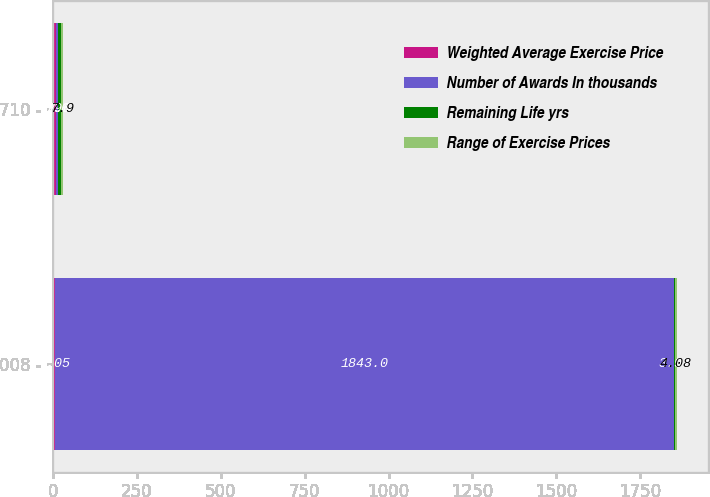Convert chart. <chart><loc_0><loc_0><loc_500><loc_500><stacked_bar_chart><ecel><fcel>008 -<fcel>710 -<nl><fcel>Weighted Average Exercise Price<fcel>7.05<fcel>7.93<nl><fcel>Number of Awards In thousands<fcel>1843<fcel>7.6<nl><fcel>Remaining Life yrs<fcel>3.97<fcel>7.6<nl><fcel>Range of Exercise Prices<fcel>4.08<fcel>7.9<nl></chart> 